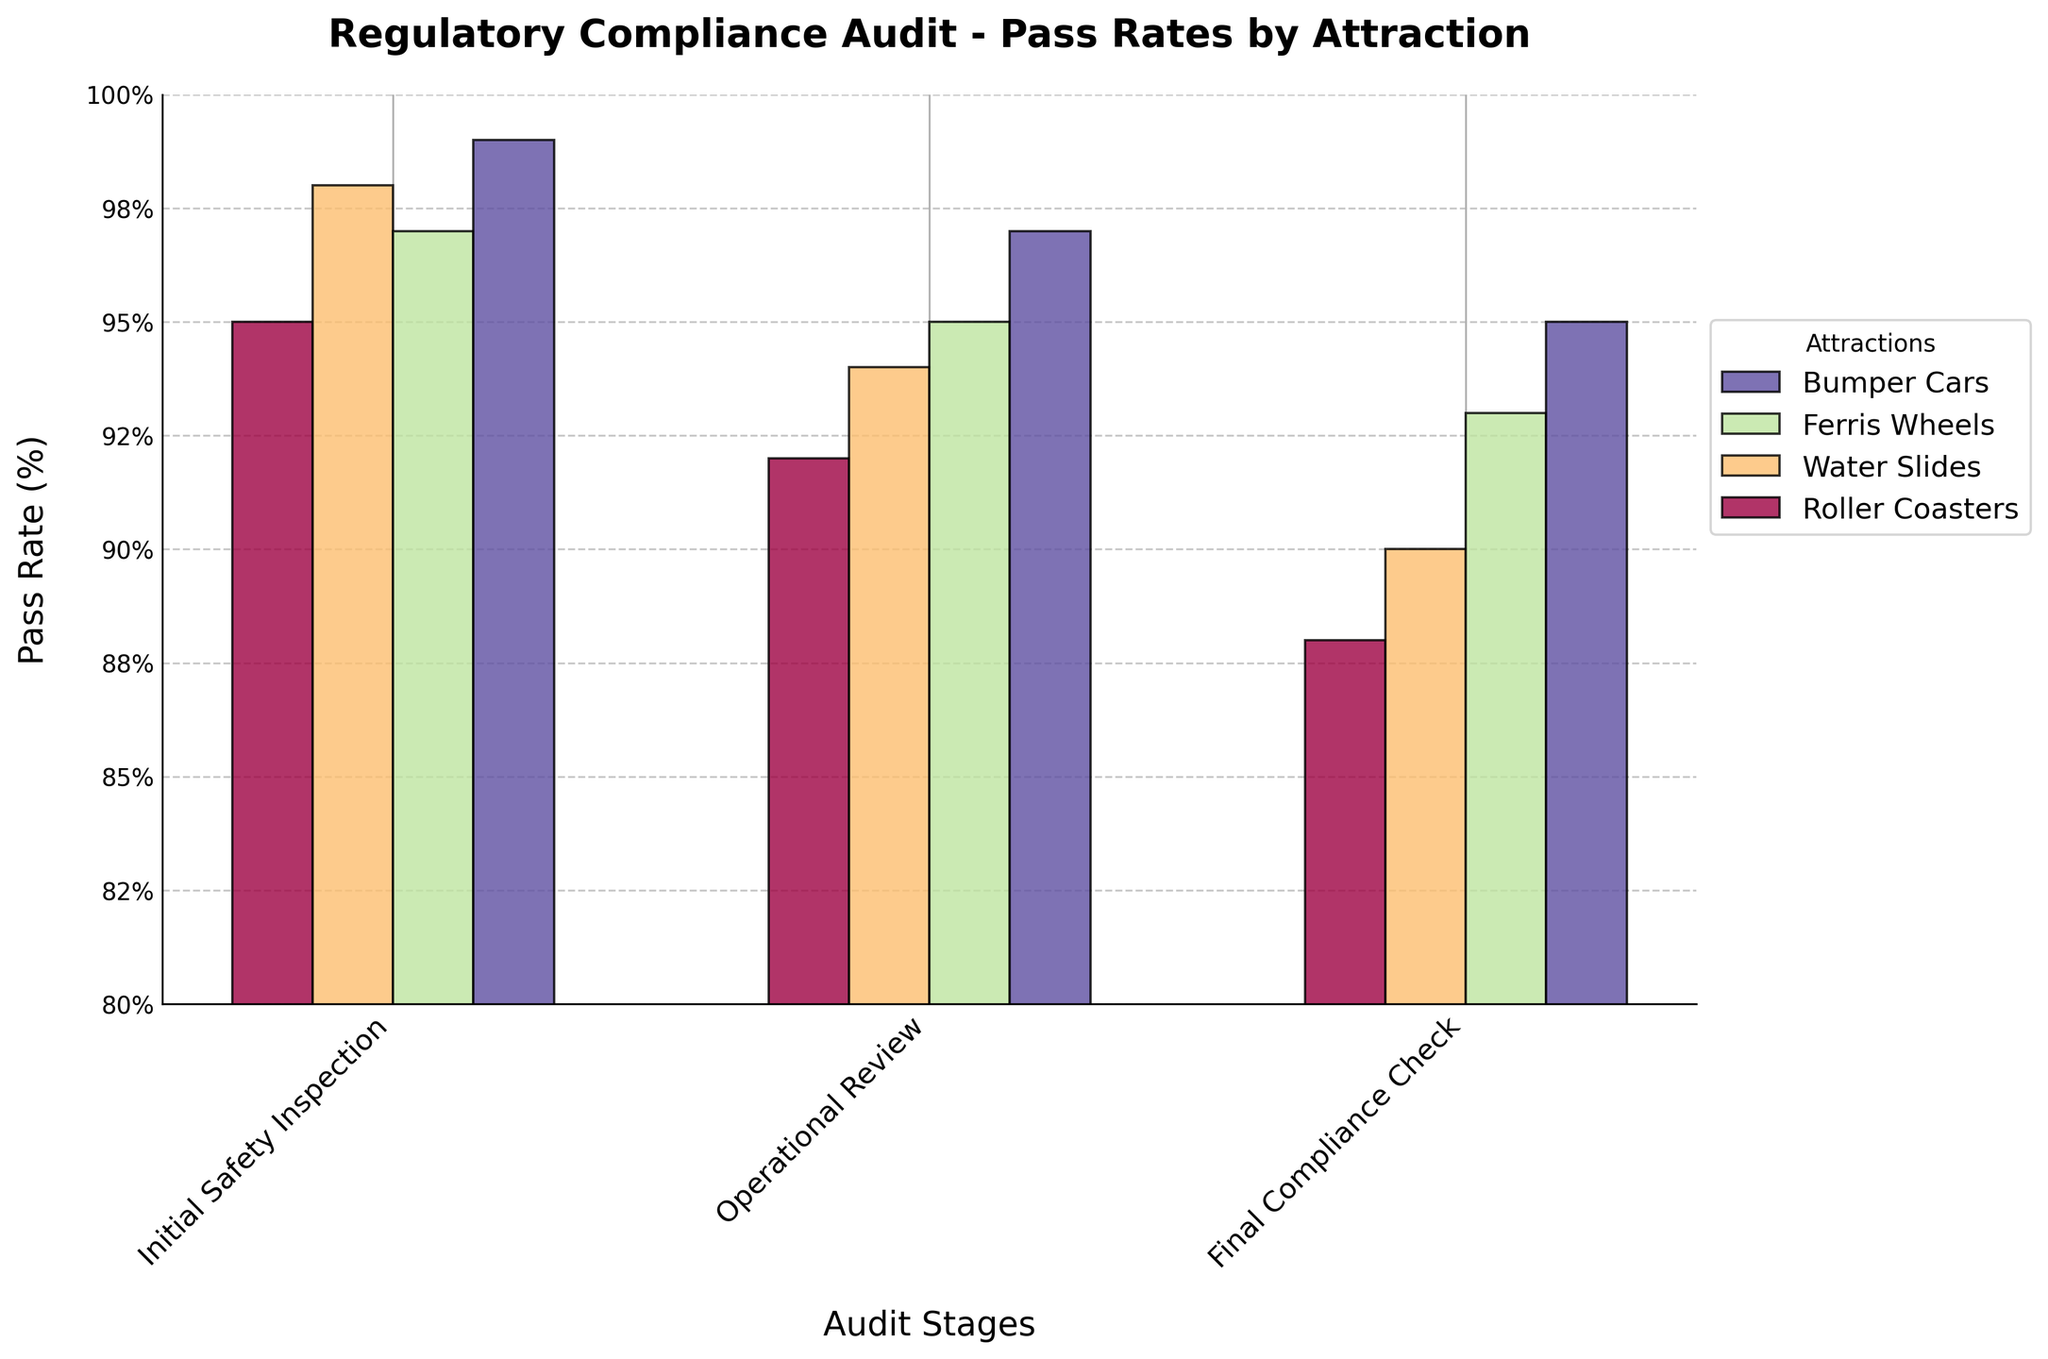What's the title of the figure? The title is at the top of the figure in bold and large font.
Answer: Regulatory Compliance Audit - Pass Rates by Attraction How many audit stages are there? The x-axis labels represent different stages. There are three labels: Initial Safety Inspection, Operational Review, and Final Compliance Check.
Answer: 3 Which attraction has the highest pass rate in the Final Compliance Check stage? Look at the bars corresponding to the Final Compliance Check stage and compare the heights. Bumper Cars have the highest bar.
Answer: Bumper Cars What is the difference in pass rate between Roller Coasters and Water Slides during the Operational Review? Look at the heights of the bars for both attractions during the Operational Review stage. The difference is (94 - 92) = 2%.
Answer: 2% Which stage shows the most significant drop in pass rates for Water Slides? Compare the drop in pass rates between the stages for Water Slides. The biggest drop is from Initial Safety Inspection (98%) to Operational Review (94%), a 4% drop.
Answer: Initial Safety Inspection to Operational Review What's the total number of attractions shown in the figure? The legend on the right lists the number of attractions. There are four listed: Roller Coasters, Water Slides, Ferris Wheels, and Bumper Cars.
Answer: 4 What is the average pass rate for Ferris Wheels across all stages? Sum the pass rates for Ferris Wheels at each stage (97 + 95 + 93) and divide by the number of stages (3). The average is (97 + 95 + 93) / 3 = 95%.
Answer: 95% How do the pass rates of Bumper Cars compare to that of Roller Coasters in the Initial Safety Inspection stage? Compare the heights of the bars for both attractions in the Initial Safety Inspection stage. Bumper Cars have a pass rate of 99%, while Roller Coasters have 95%, so Bumper Cars have a higher pass rate.
Answer: Bumper Cars have a higher pass rate By what percentage do the pass rates of Roller Coasters decline from Initial Safety Inspection to Final Compliance Check? Calculate the percentage decline from Initial Safety Inspection (95%) to Final Compliance Check (88%). The decline is ((95 - 88) / 95) * 100 = 7.37%.
Answer: 7.37% Which audit stage has the lowest overall pass rates across all attractions? Compare the heights of bars across all stages. The Final Compliance Check stage generally has the lowest bars compared to the other stages.
Answer: Final Compliance Check 